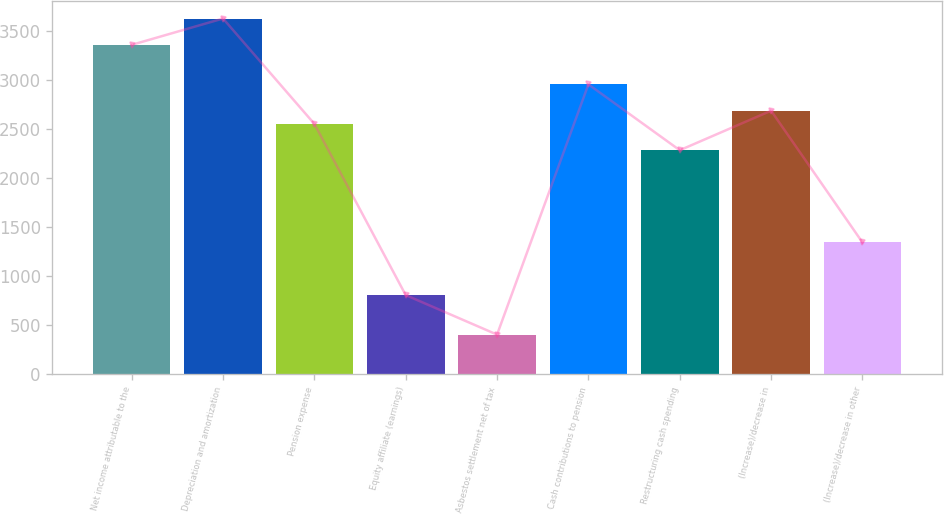Convert chart. <chart><loc_0><loc_0><loc_500><loc_500><bar_chart><fcel>Net income attributable to the<fcel>Depreciation and amortization<fcel>Pension expense<fcel>Equity affiliate (earnings)<fcel>Asbestos settlement net of tax<fcel>Cash contributions to pension<fcel>Restructuring cash spending<fcel>(Increase)/decrease in<fcel>(Increase)/decrease in other<nl><fcel>3361<fcel>3629.8<fcel>2554.6<fcel>807.4<fcel>404.2<fcel>2957.8<fcel>2285.8<fcel>2689<fcel>1345<nl></chart> 